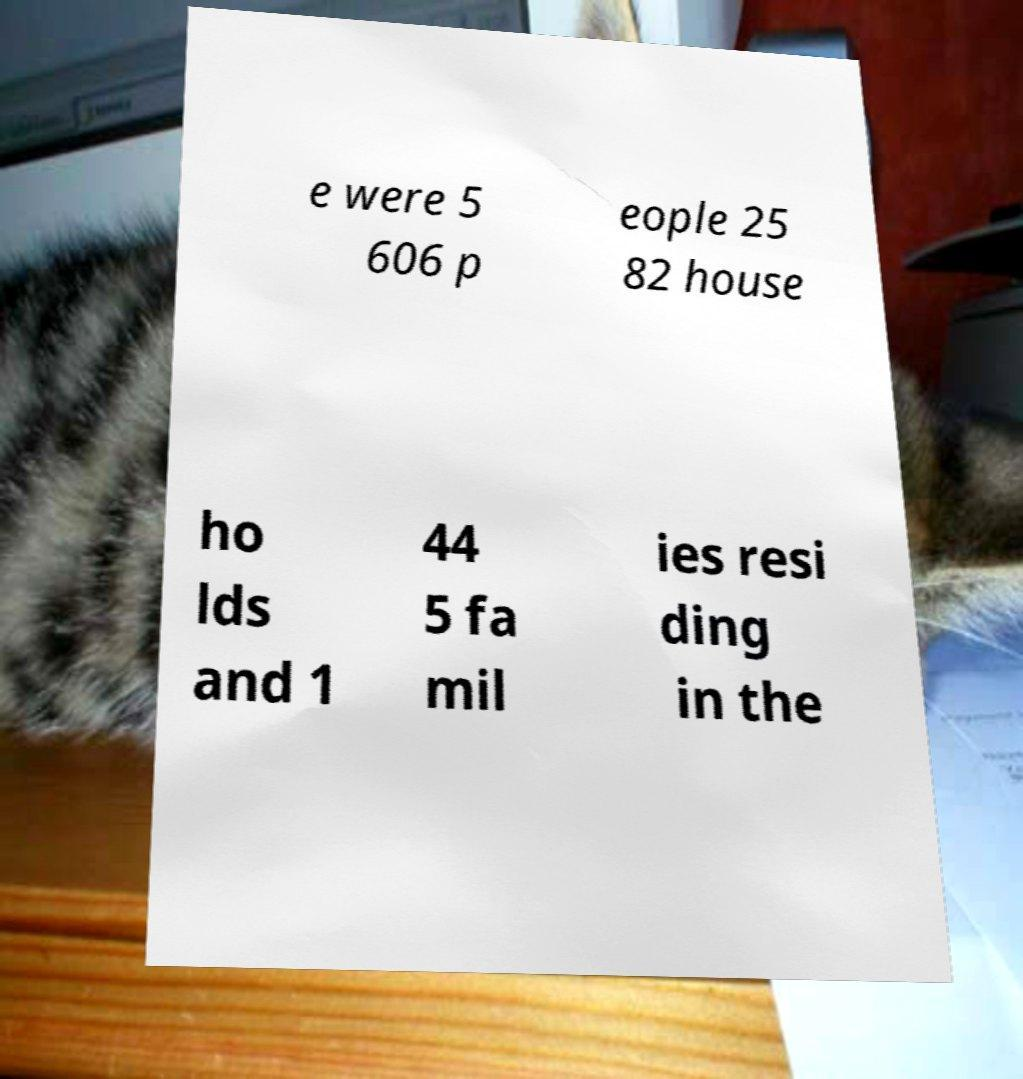There's text embedded in this image that I need extracted. Can you transcribe it verbatim? e were 5 606 p eople 25 82 house ho lds and 1 44 5 fa mil ies resi ding in the 